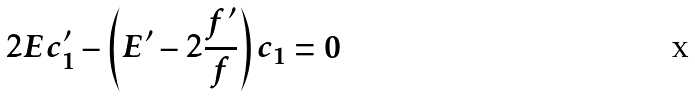Convert formula to latex. <formula><loc_0><loc_0><loc_500><loc_500>2 E c _ { 1 } ^ { \prime } - \left ( E ^ { \prime } - 2 \frac { f ^ { \prime } } { f } \right ) c _ { 1 } = 0</formula> 